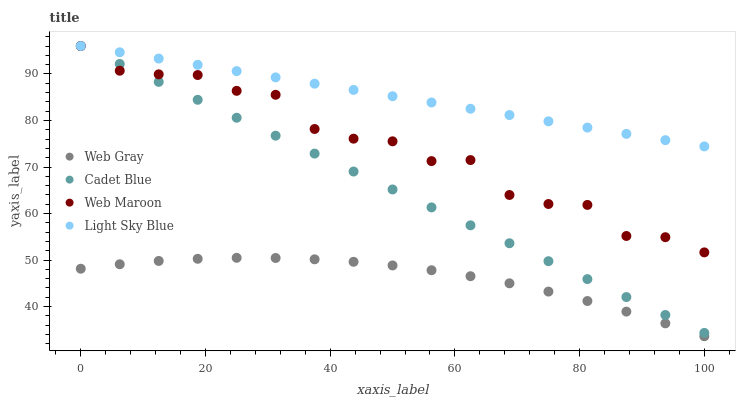Does Web Gray have the minimum area under the curve?
Answer yes or no. Yes. Does Light Sky Blue have the maximum area under the curve?
Answer yes or no. Yes. Does Web Maroon have the minimum area under the curve?
Answer yes or no. No. Does Web Maroon have the maximum area under the curve?
Answer yes or no. No. Is Cadet Blue the smoothest?
Answer yes or no. Yes. Is Web Maroon the roughest?
Answer yes or no. Yes. Is Web Gray the smoothest?
Answer yes or no. No. Is Web Gray the roughest?
Answer yes or no. No. Does Web Gray have the lowest value?
Answer yes or no. Yes. Does Web Maroon have the lowest value?
Answer yes or no. No. Does Light Sky Blue have the highest value?
Answer yes or no. Yes. Does Web Gray have the highest value?
Answer yes or no. No. Is Web Gray less than Light Sky Blue?
Answer yes or no. Yes. Is Light Sky Blue greater than Web Gray?
Answer yes or no. Yes. Does Light Sky Blue intersect Web Maroon?
Answer yes or no. Yes. Is Light Sky Blue less than Web Maroon?
Answer yes or no. No. Is Light Sky Blue greater than Web Maroon?
Answer yes or no. No. Does Web Gray intersect Light Sky Blue?
Answer yes or no. No. 